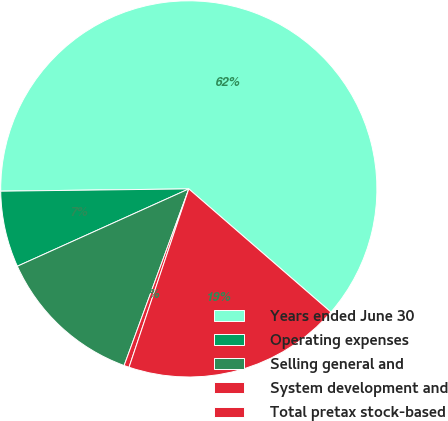<chart> <loc_0><loc_0><loc_500><loc_500><pie_chart><fcel>Years ended June 30<fcel>Operating expenses<fcel>Selling general and<fcel>System development and<fcel>Total pretax stock-based<nl><fcel>61.56%<fcel>6.55%<fcel>12.67%<fcel>0.44%<fcel>18.78%<nl></chart> 